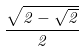Convert formula to latex. <formula><loc_0><loc_0><loc_500><loc_500>\frac { \sqrt { 2 - \sqrt { 2 } } } { 2 }</formula> 